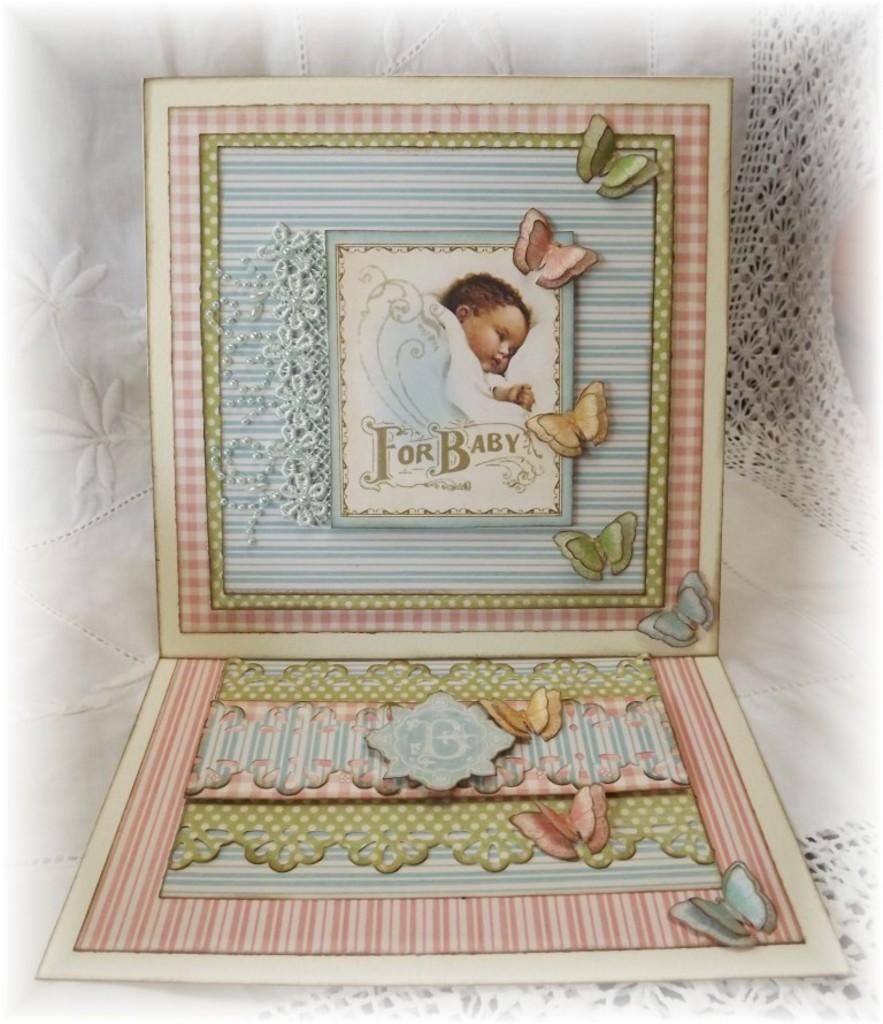<image>
Write a terse but informative summary of the picture. A baby frame has the words "For Baby" with butterflies around a picture of an infant. 